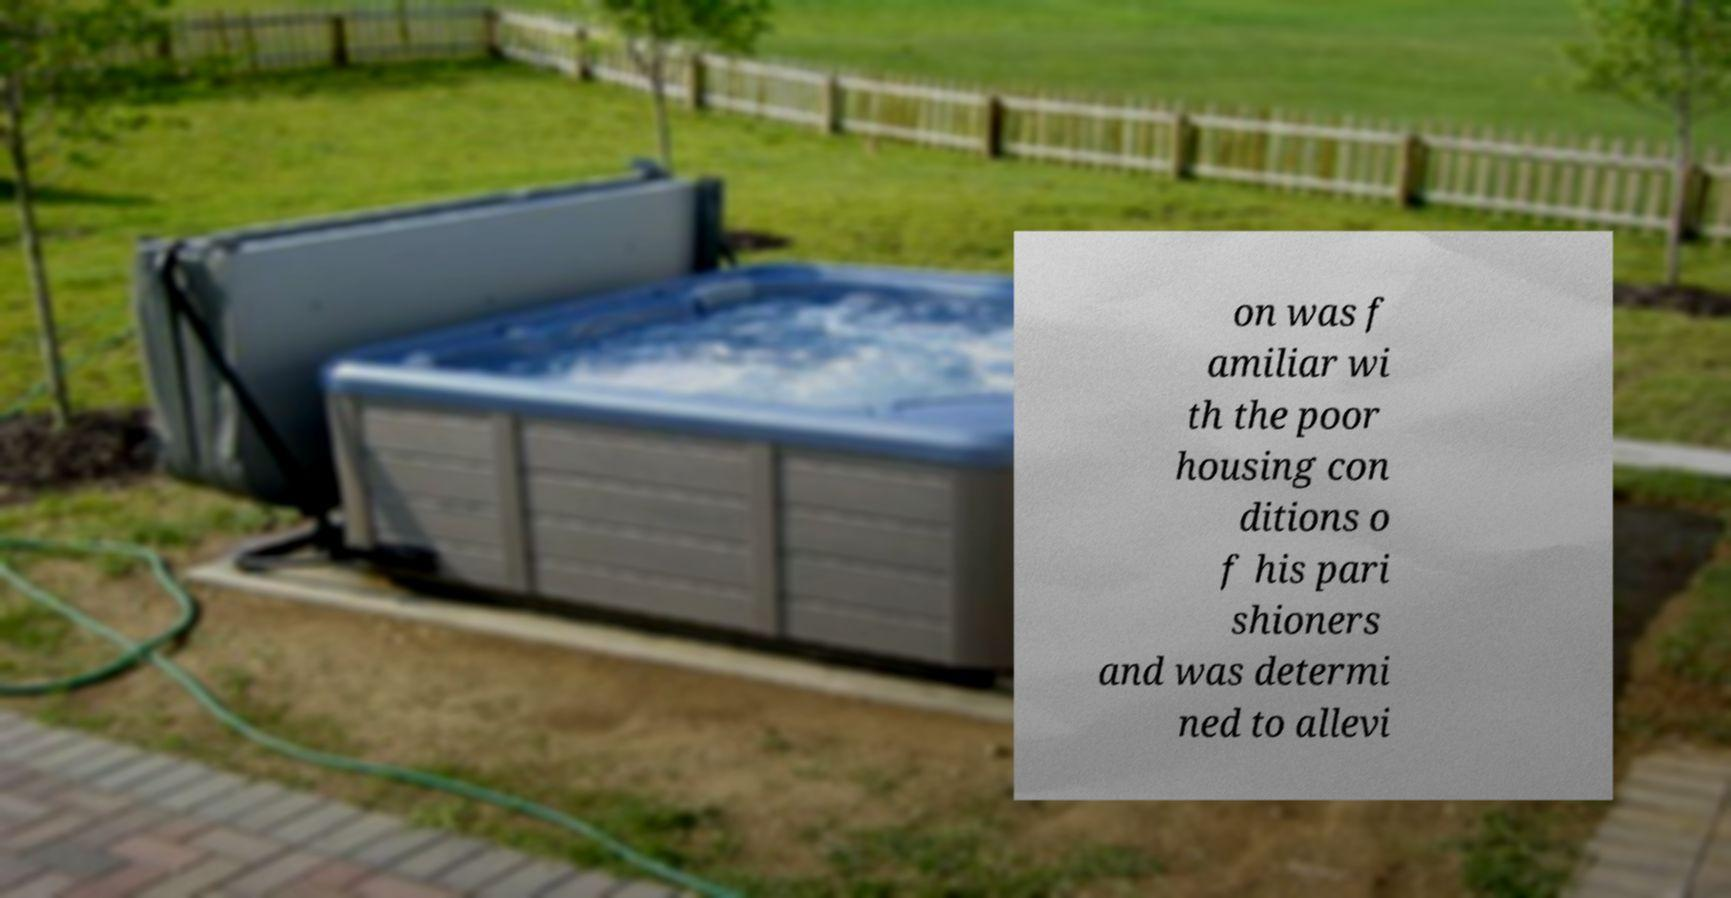Can you read and provide the text displayed in the image?This photo seems to have some interesting text. Can you extract and type it out for me? on was f amiliar wi th the poor housing con ditions o f his pari shioners and was determi ned to allevi 